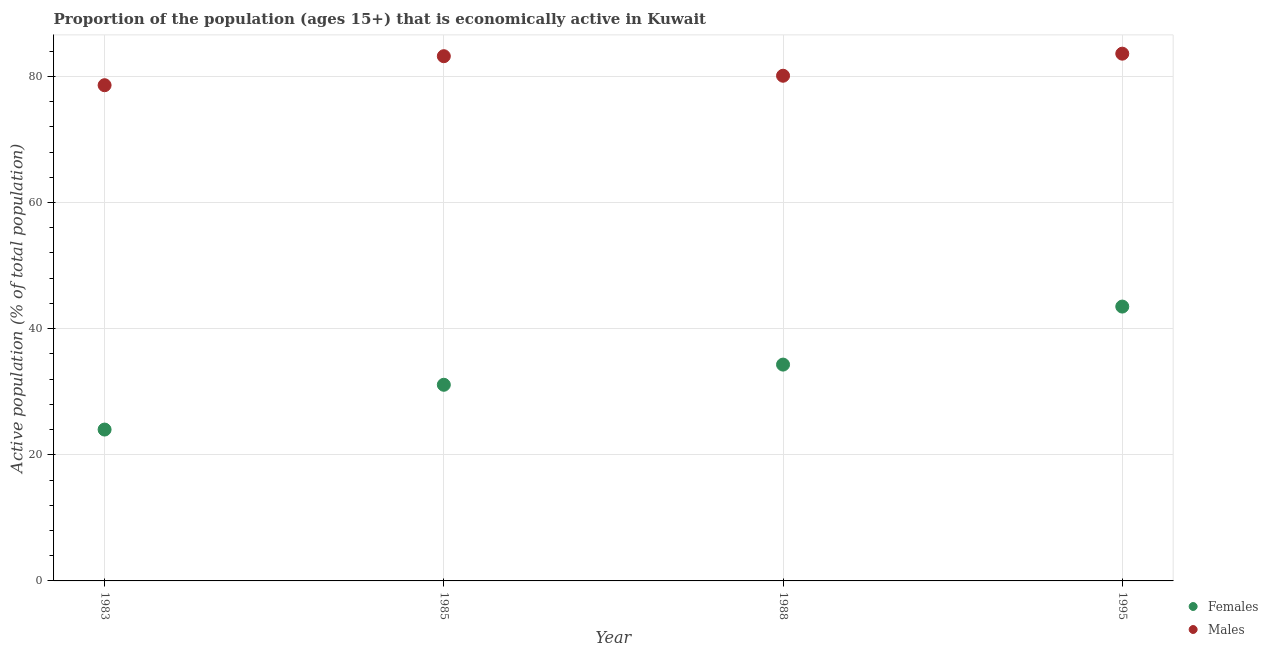How many different coloured dotlines are there?
Make the answer very short. 2. Is the number of dotlines equal to the number of legend labels?
Offer a very short reply. Yes. What is the percentage of economically active female population in 1988?
Offer a terse response. 34.3. Across all years, what is the maximum percentage of economically active male population?
Keep it short and to the point. 83.6. Across all years, what is the minimum percentage of economically active male population?
Make the answer very short. 78.6. In which year was the percentage of economically active female population maximum?
Your response must be concise. 1995. In which year was the percentage of economically active female population minimum?
Your answer should be compact. 1983. What is the total percentage of economically active female population in the graph?
Give a very brief answer. 132.9. What is the difference between the percentage of economically active female population in 1983 and the percentage of economically active male population in 1988?
Make the answer very short. -56.1. What is the average percentage of economically active male population per year?
Offer a very short reply. 81.37. In the year 1985, what is the difference between the percentage of economically active female population and percentage of economically active male population?
Give a very brief answer. -52.1. In how many years, is the percentage of economically active male population greater than 16 %?
Offer a terse response. 4. What is the ratio of the percentage of economically active male population in 1983 to that in 1988?
Make the answer very short. 0.98. Is the percentage of economically active male population in 1985 less than that in 1995?
Keep it short and to the point. Yes. What is the difference between the highest and the second highest percentage of economically active male population?
Your response must be concise. 0.4. In how many years, is the percentage of economically active female population greater than the average percentage of economically active female population taken over all years?
Offer a very short reply. 2. Does the percentage of economically active female population monotonically increase over the years?
Offer a terse response. Yes. Is the percentage of economically active female population strictly greater than the percentage of economically active male population over the years?
Offer a terse response. No. Is the percentage of economically active female population strictly less than the percentage of economically active male population over the years?
Give a very brief answer. Yes. Are the values on the major ticks of Y-axis written in scientific E-notation?
Your response must be concise. No. Where does the legend appear in the graph?
Provide a succinct answer. Bottom right. How many legend labels are there?
Make the answer very short. 2. How are the legend labels stacked?
Provide a succinct answer. Vertical. What is the title of the graph?
Give a very brief answer. Proportion of the population (ages 15+) that is economically active in Kuwait. Does "Birth rate" appear as one of the legend labels in the graph?
Your response must be concise. No. What is the label or title of the Y-axis?
Your response must be concise. Active population (% of total population). What is the Active population (% of total population) in Females in 1983?
Give a very brief answer. 24. What is the Active population (% of total population) of Males in 1983?
Your answer should be very brief. 78.6. What is the Active population (% of total population) of Females in 1985?
Ensure brevity in your answer.  31.1. What is the Active population (% of total population) of Males in 1985?
Your response must be concise. 83.2. What is the Active population (% of total population) in Females in 1988?
Offer a very short reply. 34.3. What is the Active population (% of total population) in Males in 1988?
Provide a short and direct response. 80.1. What is the Active population (% of total population) of Females in 1995?
Offer a terse response. 43.5. What is the Active population (% of total population) in Males in 1995?
Make the answer very short. 83.6. Across all years, what is the maximum Active population (% of total population) in Females?
Provide a succinct answer. 43.5. Across all years, what is the maximum Active population (% of total population) in Males?
Offer a terse response. 83.6. Across all years, what is the minimum Active population (% of total population) in Males?
Offer a terse response. 78.6. What is the total Active population (% of total population) in Females in the graph?
Ensure brevity in your answer.  132.9. What is the total Active population (% of total population) in Males in the graph?
Offer a very short reply. 325.5. What is the difference between the Active population (% of total population) in Females in 1983 and that in 1985?
Offer a terse response. -7.1. What is the difference between the Active population (% of total population) in Males in 1983 and that in 1988?
Ensure brevity in your answer.  -1.5. What is the difference between the Active population (% of total population) in Females in 1983 and that in 1995?
Make the answer very short. -19.5. What is the difference between the Active population (% of total population) in Males in 1983 and that in 1995?
Your answer should be very brief. -5. What is the difference between the Active population (% of total population) in Males in 1985 and that in 1995?
Make the answer very short. -0.4. What is the difference between the Active population (% of total population) in Females in 1988 and that in 1995?
Provide a succinct answer. -9.2. What is the difference between the Active population (% of total population) of Females in 1983 and the Active population (% of total population) of Males in 1985?
Provide a succinct answer. -59.2. What is the difference between the Active population (% of total population) of Females in 1983 and the Active population (% of total population) of Males in 1988?
Give a very brief answer. -56.1. What is the difference between the Active population (% of total population) in Females in 1983 and the Active population (% of total population) in Males in 1995?
Offer a very short reply. -59.6. What is the difference between the Active population (% of total population) in Females in 1985 and the Active population (% of total population) in Males in 1988?
Your response must be concise. -49. What is the difference between the Active population (% of total population) of Females in 1985 and the Active population (% of total population) of Males in 1995?
Give a very brief answer. -52.5. What is the difference between the Active population (% of total population) of Females in 1988 and the Active population (% of total population) of Males in 1995?
Your answer should be compact. -49.3. What is the average Active population (% of total population) in Females per year?
Your answer should be very brief. 33.23. What is the average Active population (% of total population) in Males per year?
Keep it short and to the point. 81.38. In the year 1983, what is the difference between the Active population (% of total population) in Females and Active population (% of total population) in Males?
Offer a terse response. -54.6. In the year 1985, what is the difference between the Active population (% of total population) in Females and Active population (% of total population) in Males?
Keep it short and to the point. -52.1. In the year 1988, what is the difference between the Active population (% of total population) in Females and Active population (% of total population) in Males?
Keep it short and to the point. -45.8. In the year 1995, what is the difference between the Active population (% of total population) of Females and Active population (% of total population) of Males?
Provide a short and direct response. -40.1. What is the ratio of the Active population (% of total population) in Females in 1983 to that in 1985?
Ensure brevity in your answer.  0.77. What is the ratio of the Active population (% of total population) of Males in 1983 to that in 1985?
Make the answer very short. 0.94. What is the ratio of the Active population (% of total population) in Females in 1983 to that in 1988?
Offer a very short reply. 0.7. What is the ratio of the Active population (% of total population) in Males in 1983 to that in 1988?
Your response must be concise. 0.98. What is the ratio of the Active population (% of total population) in Females in 1983 to that in 1995?
Provide a succinct answer. 0.55. What is the ratio of the Active population (% of total population) of Males in 1983 to that in 1995?
Ensure brevity in your answer.  0.94. What is the ratio of the Active population (% of total population) of Females in 1985 to that in 1988?
Offer a very short reply. 0.91. What is the ratio of the Active population (% of total population) in Males in 1985 to that in 1988?
Provide a short and direct response. 1.04. What is the ratio of the Active population (% of total population) of Females in 1985 to that in 1995?
Ensure brevity in your answer.  0.71. What is the ratio of the Active population (% of total population) in Males in 1985 to that in 1995?
Keep it short and to the point. 1. What is the ratio of the Active population (% of total population) in Females in 1988 to that in 1995?
Ensure brevity in your answer.  0.79. What is the ratio of the Active population (% of total population) in Males in 1988 to that in 1995?
Keep it short and to the point. 0.96. What is the difference between the highest and the second highest Active population (% of total population) in Females?
Your response must be concise. 9.2. What is the difference between the highest and the lowest Active population (% of total population) in Females?
Ensure brevity in your answer.  19.5. 